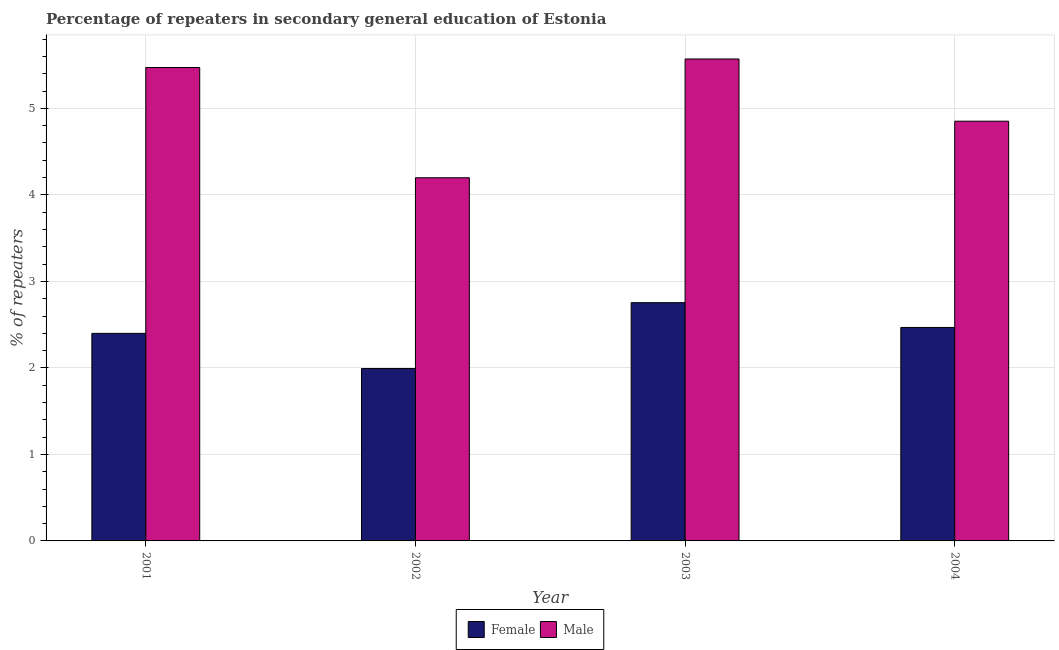How many different coloured bars are there?
Your answer should be compact. 2. Are the number of bars per tick equal to the number of legend labels?
Provide a succinct answer. Yes. Are the number of bars on each tick of the X-axis equal?
Offer a very short reply. Yes. How many bars are there on the 1st tick from the left?
Make the answer very short. 2. What is the label of the 1st group of bars from the left?
Offer a very short reply. 2001. In how many cases, is the number of bars for a given year not equal to the number of legend labels?
Your answer should be very brief. 0. What is the percentage of female repeaters in 2002?
Provide a short and direct response. 1.99. Across all years, what is the maximum percentage of male repeaters?
Your answer should be compact. 5.57. Across all years, what is the minimum percentage of female repeaters?
Ensure brevity in your answer.  1.99. In which year was the percentage of male repeaters maximum?
Ensure brevity in your answer.  2003. What is the total percentage of male repeaters in the graph?
Your answer should be very brief. 20.09. What is the difference between the percentage of female repeaters in 2002 and that in 2003?
Keep it short and to the point. -0.76. What is the difference between the percentage of male repeaters in 2001 and the percentage of female repeaters in 2003?
Keep it short and to the point. -0.1. What is the average percentage of female repeaters per year?
Your response must be concise. 2.4. What is the ratio of the percentage of male repeaters in 2001 to that in 2004?
Your response must be concise. 1.13. Is the difference between the percentage of female repeaters in 2002 and 2004 greater than the difference between the percentage of male repeaters in 2002 and 2004?
Keep it short and to the point. No. What is the difference between the highest and the second highest percentage of female repeaters?
Keep it short and to the point. 0.29. What is the difference between the highest and the lowest percentage of male repeaters?
Offer a very short reply. 1.37. Is the sum of the percentage of male repeaters in 2002 and 2004 greater than the maximum percentage of female repeaters across all years?
Offer a very short reply. Yes. What does the 1st bar from the right in 2003 represents?
Provide a succinct answer. Male. How many bars are there?
Keep it short and to the point. 8. How many years are there in the graph?
Offer a terse response. 4. What is the difference between two consecutive major ticks on the Y-axis?
Your answer should be compact. 1. Are the values on the major ticks of Y-axis written in scientific E-notation?
Your answer should be compact. No. Does the graph contain grids?
Your response must be concise. Yes. How many legend labels are there?
Offer a very short reply. 2. What is the title of the graph?
Offer a very short reply. Percentage of repeaters in secondary general education of Estonia. What is the label or title of the X-axis?
Provide a short and direct response. Year. What is the label or title of the Y-axis?
Provide a short and direct response. % of repeaters. What is the % of repeaters in Female in 2001?
Your answer should be very brief. 2.4. What is the % of repeaters in Male in 2001?
Your answer should be very brief. 5.47. What is the % of repeaters of Female in 2002?
Your answer should be compact. 1.99. What is the % of repeaters in Male in 2002?
Give a very brief answer. 4.2. What is the % of repeaters of Female in 2003?
Your response must be concise. 2.75. What is the % of repeaters of Male in 2003?
Keep it short and to the point. 5.57. What is the % of repeaters in Female in 2004?
Offer a very short reply. 2.47. What is the % of repeaters of Male in 2004?
Provide a short and direct response. 4.85. Across all years, what is the maximum % of repeaters in Female?
Give a very brief answer. 2.75. Across all years, what is the maximum % of repeaters in Male?
Ensure brevity in your answer.  5.57. Across all years, what is the minimum % of repeaters in Female?
Your response must be concise. 1.99. Across all years, what is the minimum % of repeaters in Male?
Ensure brevity in your answer.  4.2. What is the total % of repeaters of Female in the graph?
Ensure brevity in your answer.  9.61. What is the total % of repeaters in Male in the graph?
Provide a short and direct response. 20.09. What is the difference between the % of repeaters in Female in 2001 and that in 2002?
Your response must be concise. 0.41. What is the difference between the % of repeaters of Male in 2001 and that in 2002?
Offer a very short reply. 1.27. What is the difference between the % of repeaters in Female in 2001 and that in 2003?
Give a very brief answer. -0.35. What is the difference between the % of repeaters in Male in 2001 and that in 2003?
Your response must be concise. -0.1. What is the difference between the % of repeaters in Female in 2001 and that in 2004?
Ensure brevity in your answer.  -0.07. What is the difference between the % of repeaters in Male in 2001 and that in 2004?
Ensure brevity in your answer.  0.62. What is the difference between the % of repeaters of Female in 2002 and that in 2003?
Offer a very short reply. -0.76. What is the difference between the % of repeaters in Male in 2002 and that in 2003?
Keep it short and to the point. -1.37. What is the difference between the % of repeaters in Female in 2002 and that in 2004?
Your answer should be compact. -0.47. What is the difference between the % of repeaters of Male in 2002 and that in 2004?
Your answer should be very brief. -0.65. What is the difference between the % of repeaters of Female in 2003 and that in 2004?
Offer a terse response. 0.29. What is the difference between the % of repeaters in Male in 2003 and that in 2004?
Ensure brevity in your answer.  0.72. What is the difference between the % of repeaters in Female in 2001 and the % of repeaters in Male in 2002?
Your answer should be very brief. -1.8. What is the difference between the % of repeaters in Female in 2001 and the % of repeaters in Male in 2003?
Your answer should be very brief. -3.17. What is the difference between the % of repeaters in Female in 2001 and the % of repeaters in Male in 2004?
Make the answer very short. -2.45. What is the difference between the % of repeaters in Female in 2002 and the % of repeaters in Male in 2003?
Give a very brief answer. -3.58. What is the difference between the % of repeaters of Female in 2002 and the % of repeaters of Male in 2004?
Your answer should be compact. -2.86. What is the difference between the % of repeaters of Female in 2003 and the % of repeaters of Male in 2004?
Your answer should be compact. -2.1. What is the average % of repeaters of Female per year?
Offer a very short reply. 2.4. What is the average % of repeaters of Male per year?
Offer a very short reply. 5.02. In the year 2001, what is the difference between the % of repeaters of Female and % of repeaters of Male?
Offer a terse response. -3.07. In the year 2002, what is the difference between the % of repeaters in Female and % of repeaters in Male?
Keep it short and to the point. -2.21. In the year 2003, what is the difference between the % of repeaters of Female and % of repeaters of Male?
Your answer should be very brief. -2.82. In the year 2004, what is the difference between the % of repeaters of Female and % of repeaters of Male?
Your response must be concise. -2.38. What is the ratio of the % of repeaters of Female in 2001 to that in 2002?
Ensure brevity in your answer.  1.2. What is the ratio of the % of repeaters of Male in 2001 to that in 2002?
Provide a short and direct response. 1.3. What is the ratio of the % of repeaters in Female in 2001 to that in 2003?
Keep it short and to the point. 0.87. What is the ratio of the % of repeaters of Male in 2001 to that in 2003?
Ensure brevity in your answer.  0.98. What is the ratio of the % of repeaters in Female in 2001 to that in 2004?
Your answer should be compact. 0.97. What is the ratio of the % of repeaters of Male in 2001 to that in 2004?
Offer a terse response. 1.13. What is the ratio of the % of repeaters of Female in 2002 to that in 2003?
Offer a terse response. 0.72. What is the ratio of the % of repeaters in Male in 2002 to that in 2003?
Give a very brief answer. 0.75. What is the ratio of the % of repeaters in Female in 2002 to that in 2004?
Keep it short and to the point. 0.81. What is the ratio of the % of repeaters of Male in 2002 to that in 2004?
Provide a short and direct response. 0.87. What is the ratio of the % of repeaters in Female in 2003 to that in 2004?
Your answer should be very brief. 1.12. What is the ratio of the % of repeaters of Male in 2003 to that in 2004?
Offer a terse response. 1.15. What is the difference between the highest and the second highest % of repeaters in Female?
Your response must be concise. 0.29. What is the difference between the highest and the second highest % of repeaters in Male?
Ensure brevity in your answer.  0.1. What is the difference between the highest and the lowest % of repeaters of Female?
Make the answer very short. 0.76. What is the difference between the highest and the lowest % of repeaters in Male?
Ensure brevity in your answer.  1.37. 